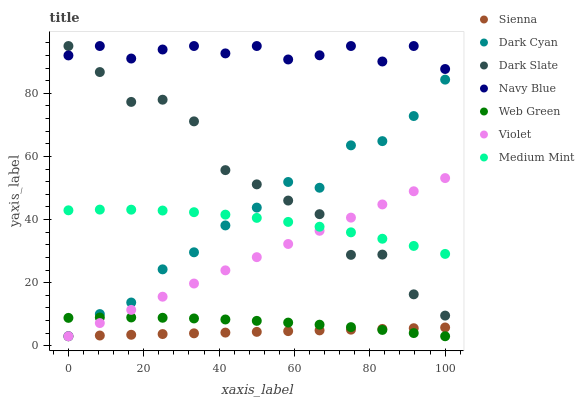Does Sienna have the minimum area under the curve?
Answer yes or no. Yes. Does Navy Blue have the maximum area under the curve?
Answer yes or no. Yes. Does Web Green have the minimum area under the curve?
Answer yes or no. No. Does Web Green have the maximum area under the curve?
Answer yes or no. No. Is Sienna the smoothest?
Answer yes or no. Yes. Is Dark Slate the roughest?
Answer yes or no. Yes. Is Navy Blue the smoothest?
Answer yes or no. No. Is Navy Blue the roughest?
Answer yes or no. No. Does Web Green have the lowest value?
Answer yes or no. Yes. Does Navy Blue have the lowest value?
Answer yes or no. No. Does Dark Slate have the highest value?
Answer yes or no. Yes. Does Web Green have the highest value?
Answer yes or no. No. Is Web Green less than Medium Mint?
Answer yes or no. Yes. Is Navy Blue greater than Medium Mint?
Answer yes or no. Yes. Does Dark Cyan intersect Medium Mint?
Answer yes or no. Yes. Is Dark Cyan less than Medium Mint?
Answer yes or no. No. Is Dark Cyan greater than Medium Mint?
Answer yes or no. No. Does Web Green intersect Medium Mint?
Answer yes or no. No. 